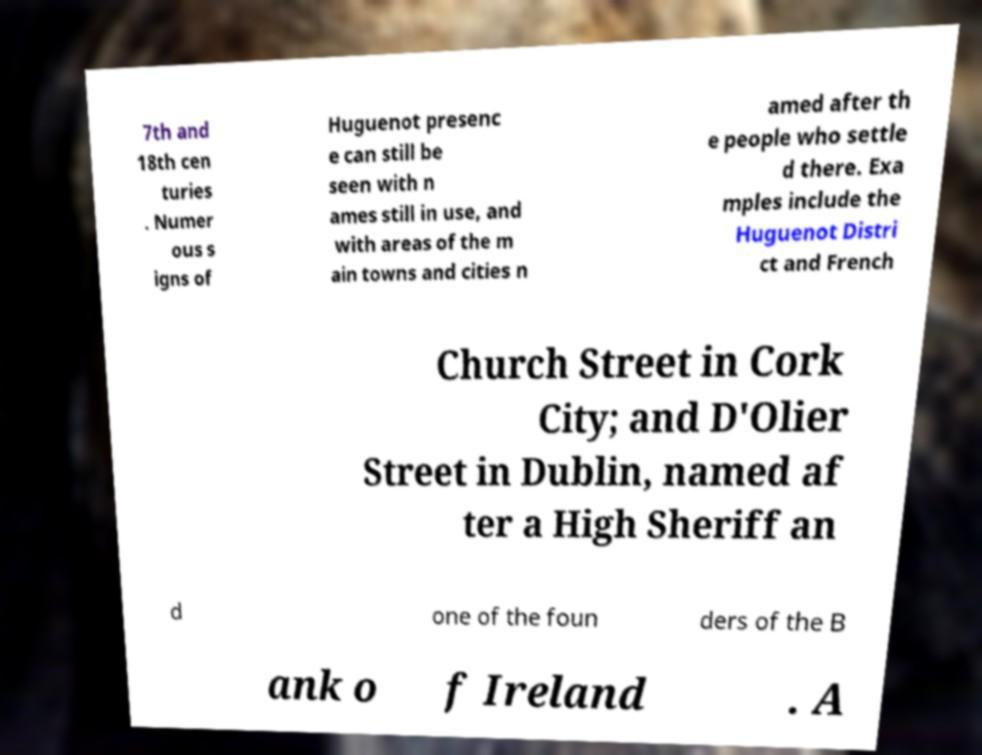Please read and relay the text visible in this image. What does it say? 7th and 18th cen turies . Numer ous s igns of Huguenot presenc e can still be seen with n ames still in use, and with areas of the m ain towns and cities n amed after th e people who settle d there. Exa mples include the Huguenot Distri ct and French Church Street in Cork City; and D'Olier Street in Dublin, named af ter a High Sheriff an d one of the foun ders of the B ank o f Ireland . A 